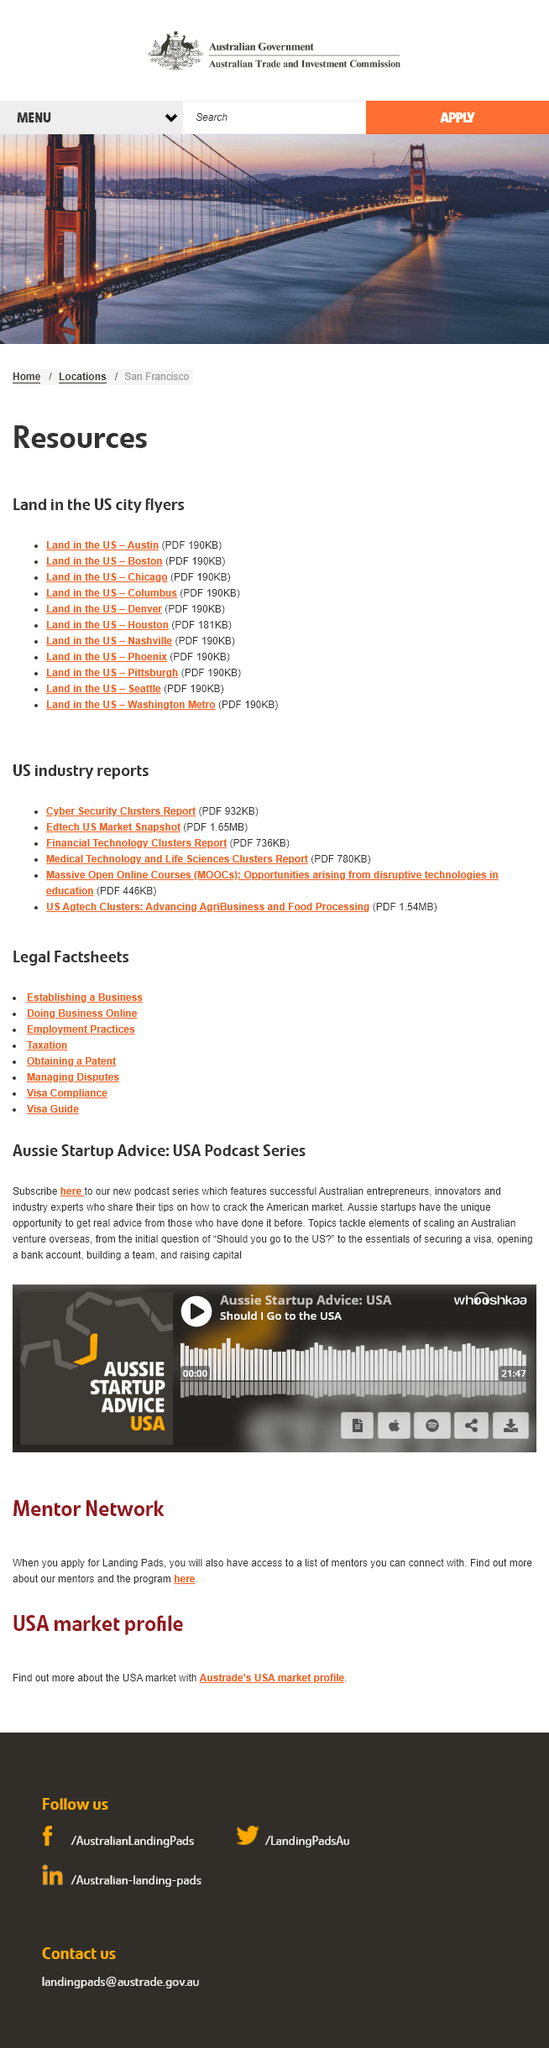Indicate a few pertinent items in this graphic. The title of this specific podcast episode is 'Should I Go to the USA?', which asks listeners to consider the pros and cons of traveling to the United States of America. The podcast is approximately 21 minutes and 47 seconds in length. The podcast is called 'Aussie Startup Advice: USA'. 